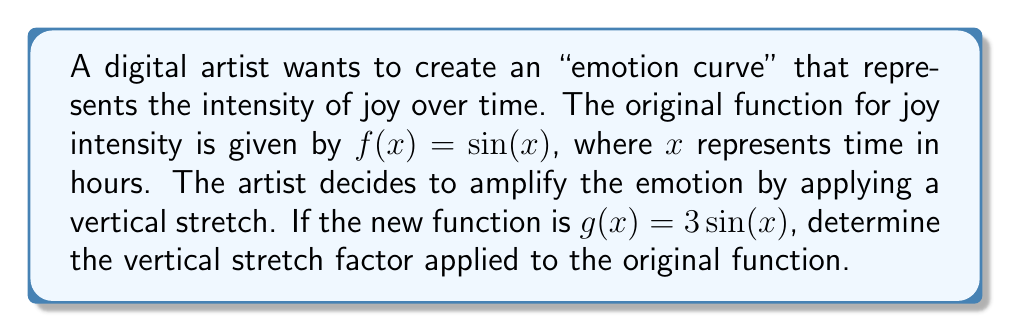Can you solve this math problem? To determine the vertical stretch factor, we need to compare the new function $g(x)$ with the original function $f(x)$:

1. Original function: $f(x) = \sin(x)$
2. New function: $g(x) = 3\sin(x)$

The general form of a vertical stretch or compression is:

$g(x) = a \cdot f(x)$

Where $a$ is the stretch factor:
- If $|a| > 1$, it's a vertical stretch
- If $0 < |a| < 1$, it's a vertical compression

In this case:

$g(x) = 3\sin(x) = 3 \cdot f(x)$

We can see that $a = 3$

Since $|a| = |3| > 1$, this is a vertical stretch.

The stretch factor is 3, meaning the graph of $g(x)$ is stretched vertically by a factor of 3 compared to the original function $f(x)$.
Answer: 3 